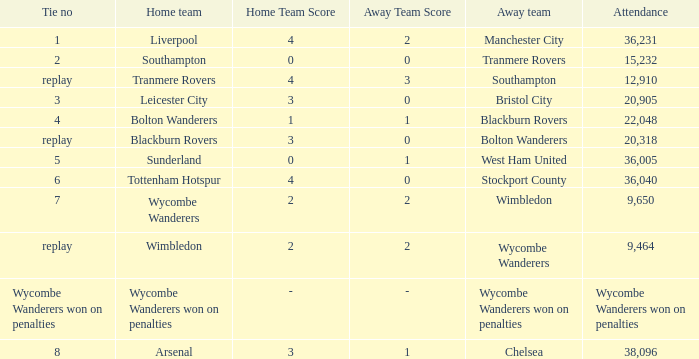What was the score for the game where the home team was Wycombe Wanderers? 2 – 2. 